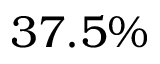Convert formula to latex. <formula><loc_0><loc_0><loc_500><loc_500>3 7 . 5 \%</formula> 